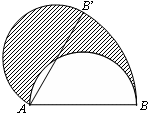Point out the elements visible in the diagram. In the diagram, there is a semicircle with diameter AB. The center of the semicircle is point A, and there are two points, B and B', on the circumference of the semicircle. The semicircle is divided into two regions, one of which is shaded. Moreover, there is a sector formed by points A, B, and B'. 